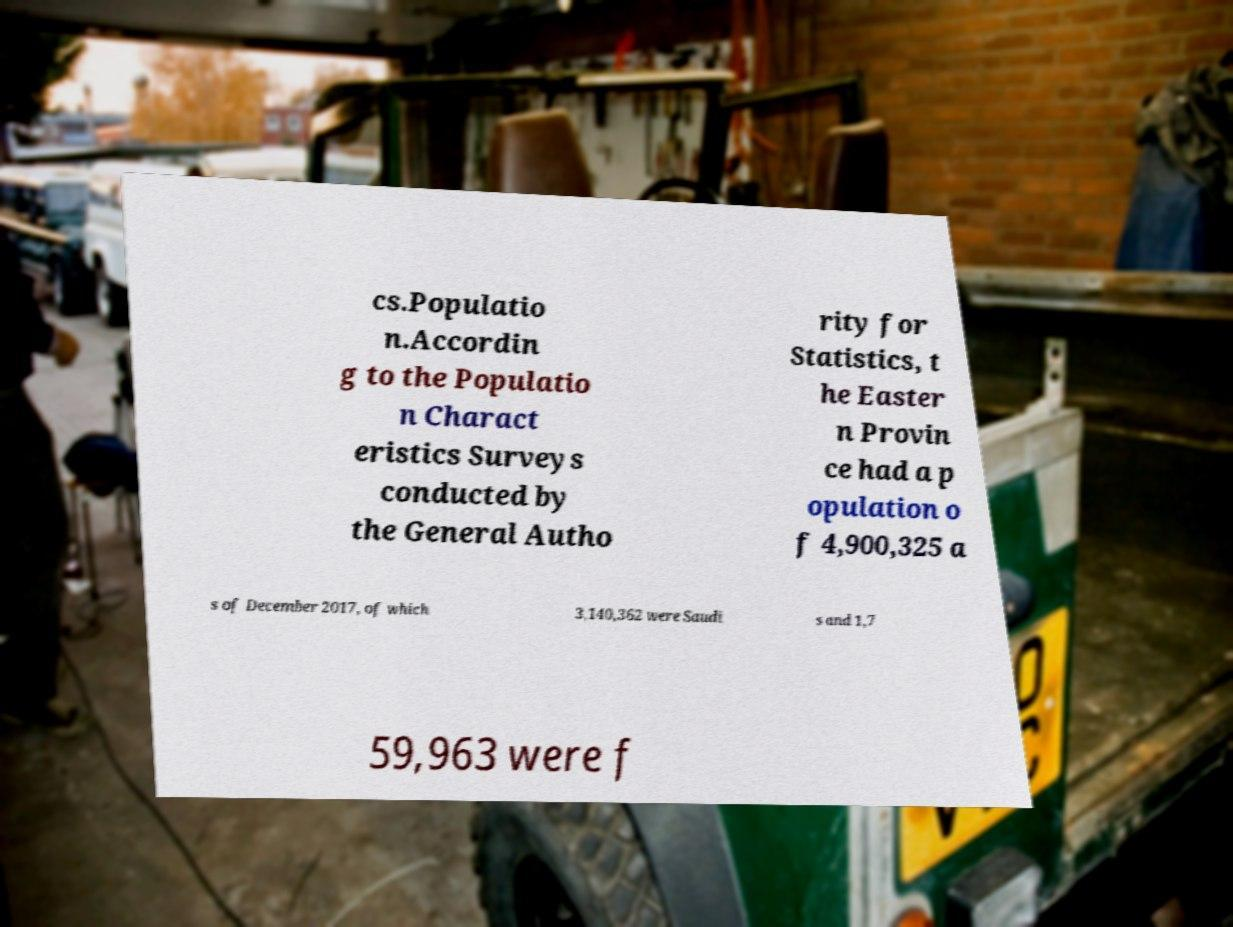There's text embedded in this image that I need extracted. Can you transcribe it verbatim? cs.Populatio n.Accordin g to the Populatio n Charact eristics Surveys conducted by the General Autho rity for Statistics, t he Easter n Provin ce had a p opulation o f 4,900,325 a s of December 2017, of which 3,140,362 were Saudi s and 1,7 59,963 were f 